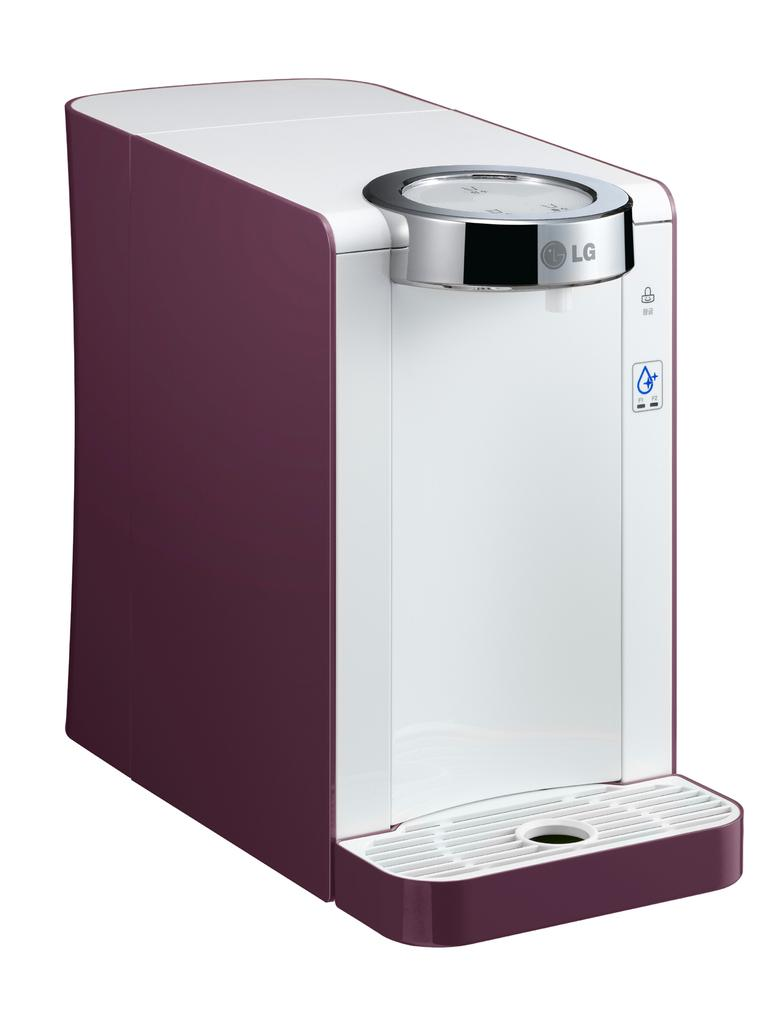<image>
Summarize the visual content of the image. A coffee maker by LG has a maroon coloring. 